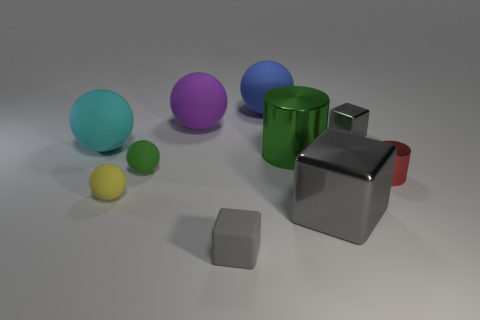Subtract all shiny cubes. How many cubes are left? 1 Subtract all yellow balls. How many balls are left? 4 Subtract all purple cylinders. Subtract all cyan cubes. How many cylinders are left? 2 Subtract all cyan rubber balls. Subtract all big blue balls. How many objects are left? 8 Add 6 small gray rubber things. How many small gray rubber things are left? 7 Add 7 tiny metal things. How many tiny metal things exist? 9 Subtract 0 gray cylinders. How many objects are left? 10 Subtract all cylinders. How many objects are left? 8 Subtract 3 balls. How many balls are left? 2 